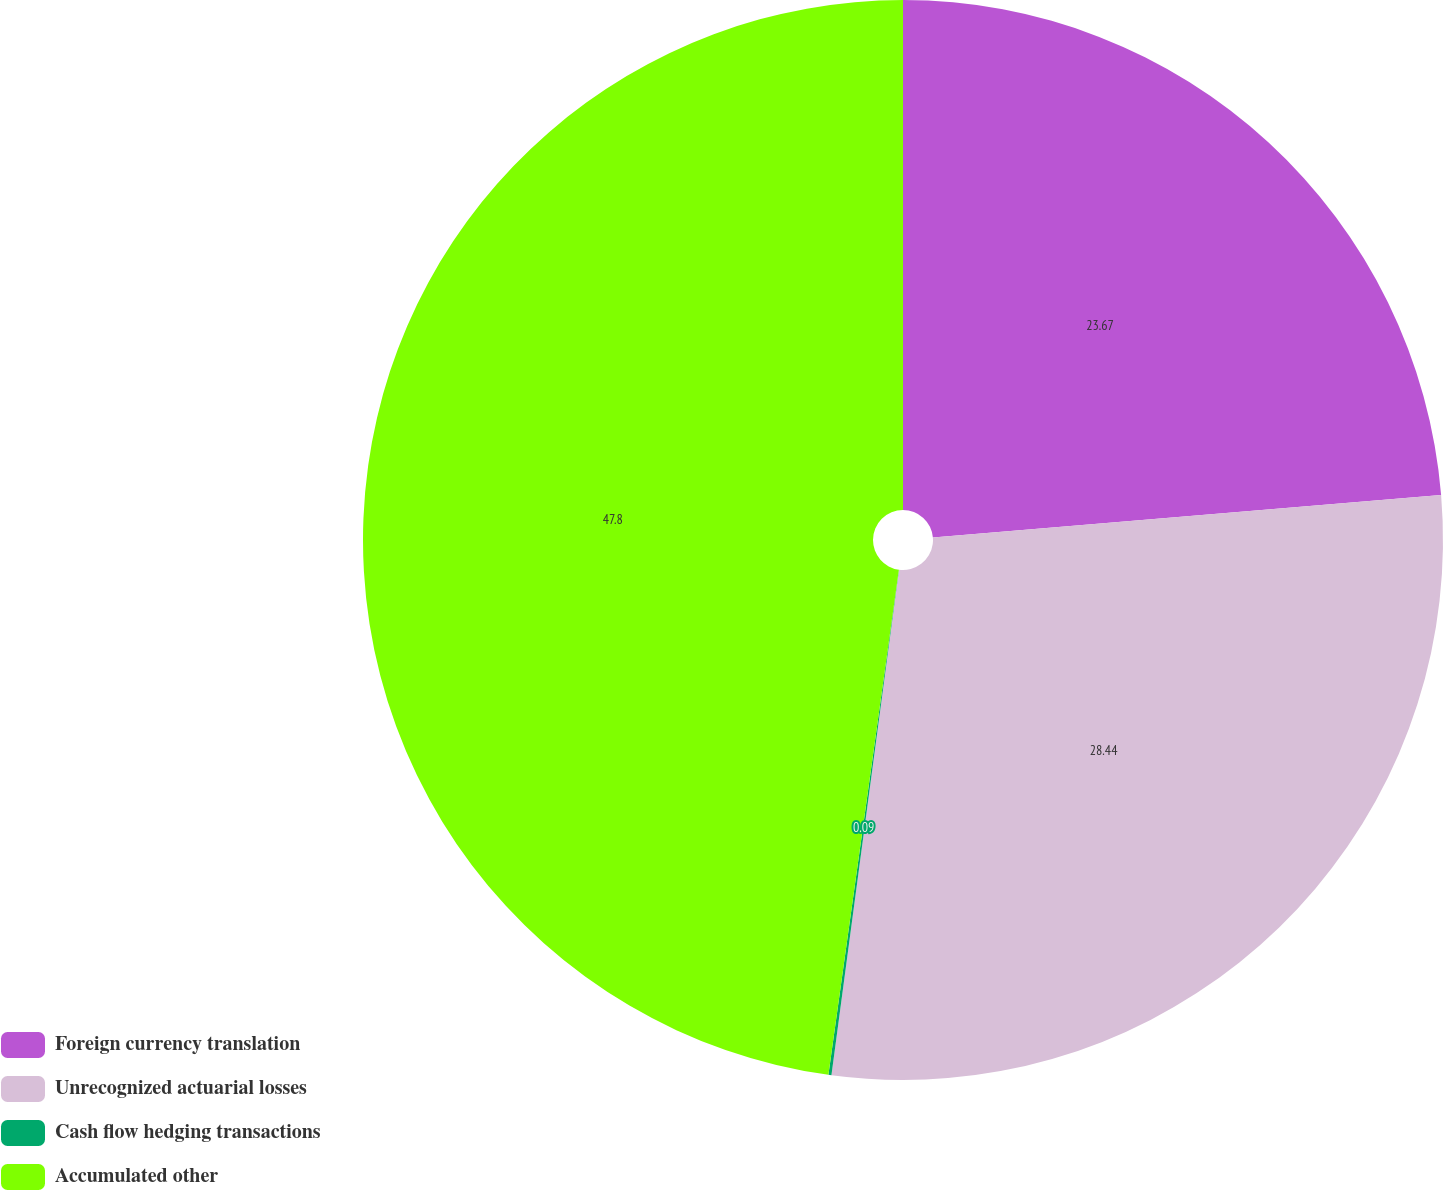Convert chart to OTSL. <chart><loc_0><loc_0><loc_500><loc_500><pie_chart><fcel>Foreign currency translation<fcel>Unrecognized actuarial losses<fcel>Cash flow hedging transactions<fcel>Accumulated other<nl><fcel>23.67%<fcel>28.44%<fcel>0.09%<fcel>47.79%<nl></chart> 